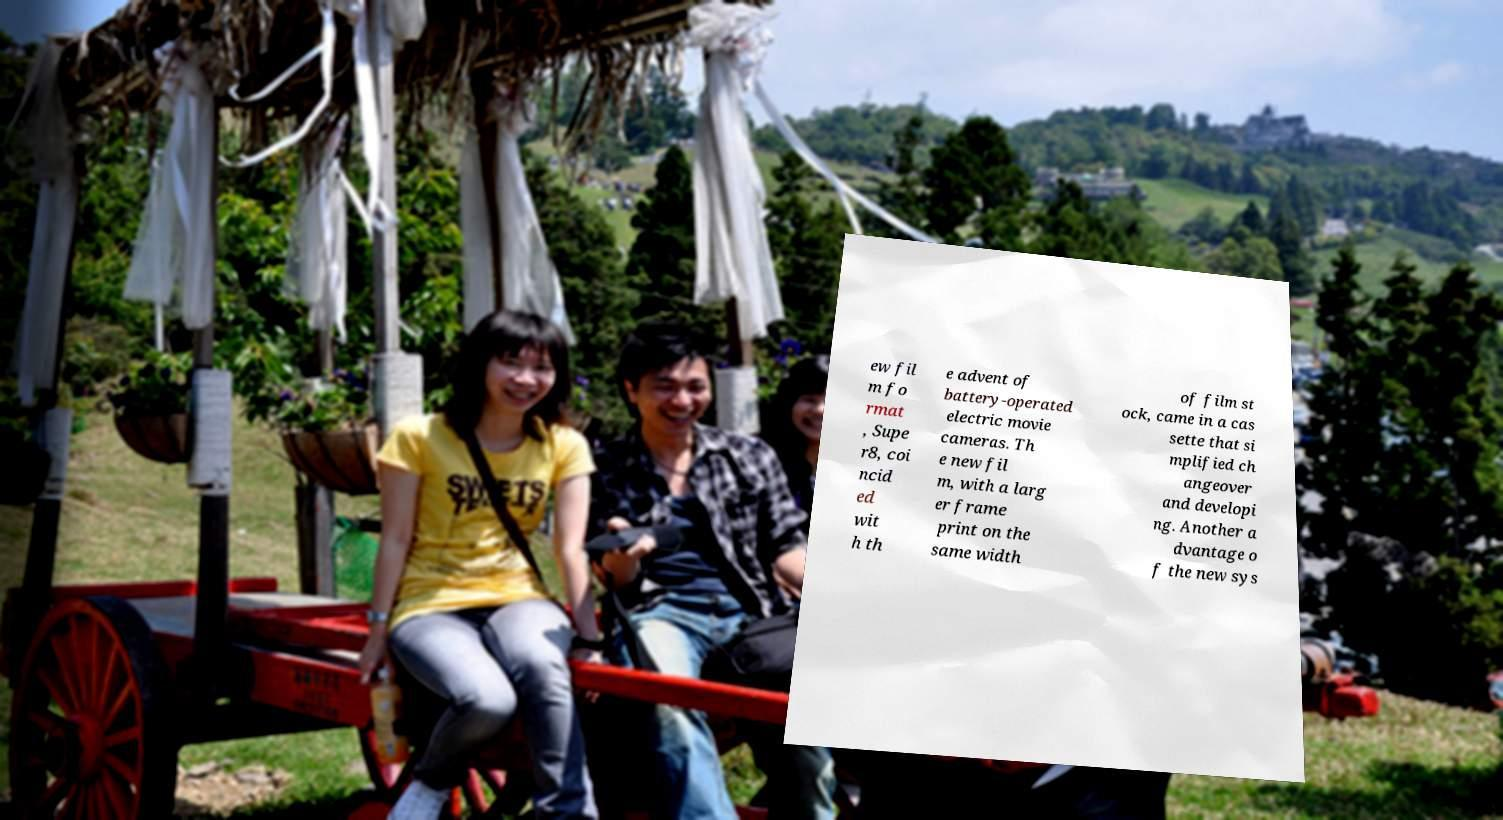Can you read and provide the text displayed in the image?This photo seems to have some interesting text. Can you extract and type it out for me? ew fil m fo rmat , Supe r8, coi ncid ed wit h th e advent of battery-operated electric movie cameras. Th e new fil m, with a larg er frame print on the same width of film st ock, came in a cas sette that si mplified ch angeover and developi ng. Another a dvantage o f the new sys 